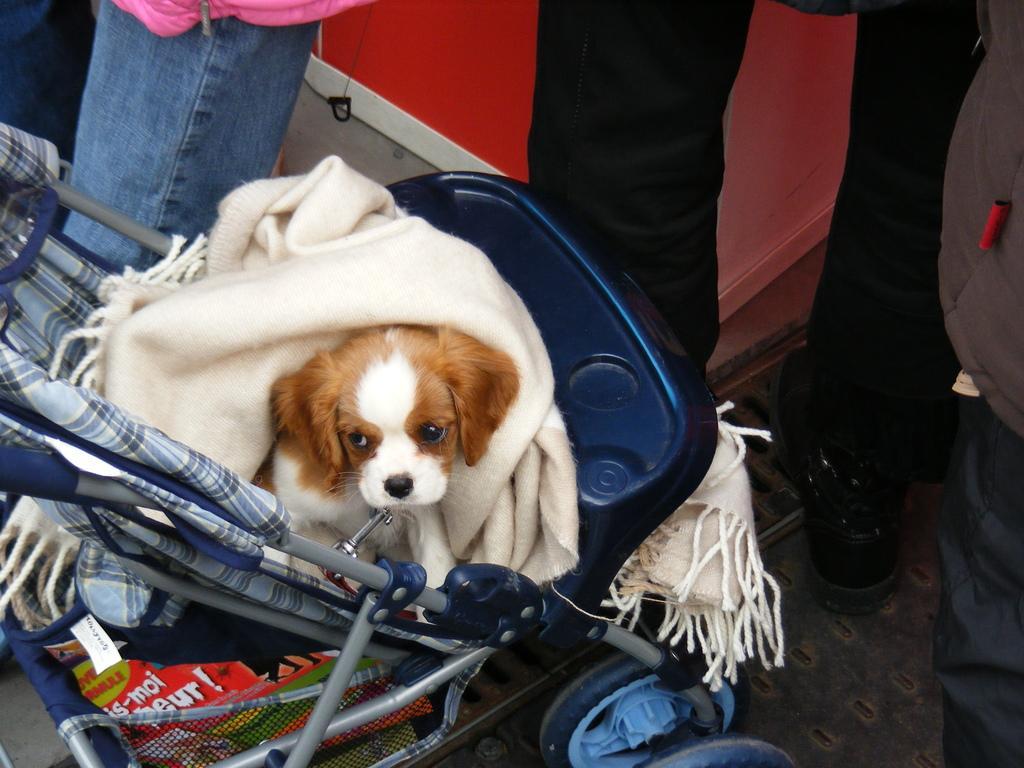How would you summarize this image in a sentence or two? There is a dog with a cloth is sitting on a stroller. In the stroller there are some other things. Also some people are there. 